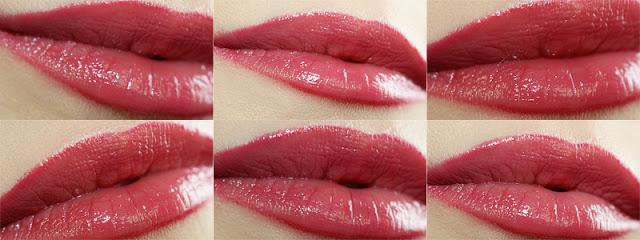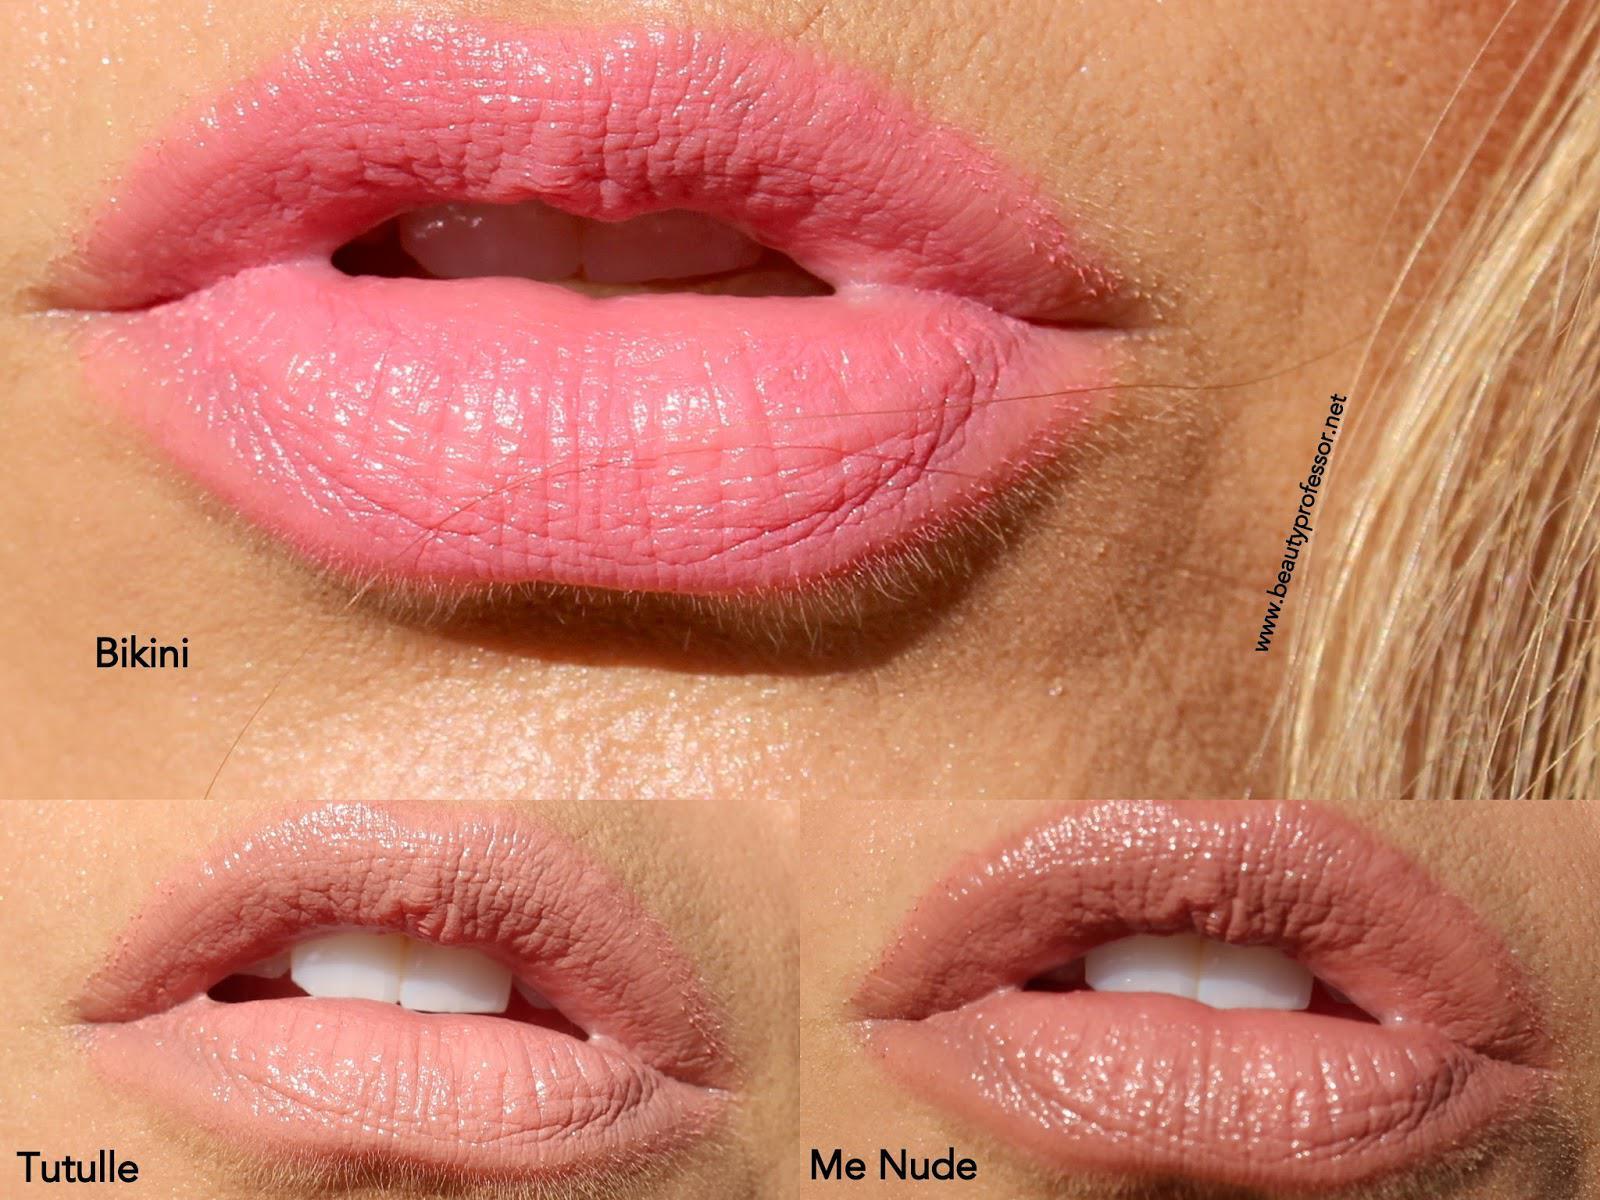The first image is the image on the left, the second image is the image on the right. Assess this claim about the two images: "There are more than six pairs of lips in total.". Correct or not? Answer yes or no. Yes. The first image is the image on the left, the second image is the image on the right. For the images shown, is this caption "The image on the right shows on pair of lips wearing makeup." true? Answer yes or no. No. 